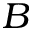<formula> <loc_0><loc_0><loc_500><loc_500>B</formula> 